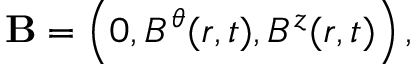<formula> <loc_0><loc_0><loc_500><loc_500>{ B } = \left ( { 0 , B ^ { \theta } ( r , t ) , B ^ { z } ( r , t ) } \right ) ,</formula> 